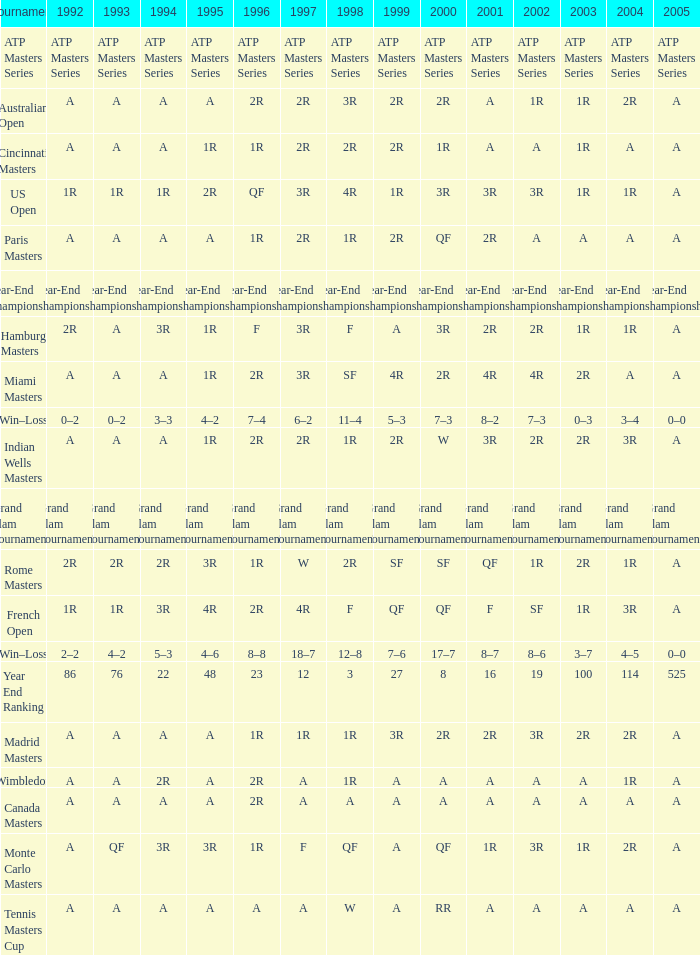What is 1998, when 1997 is "3R", and when 1992 is "A"? SF. 